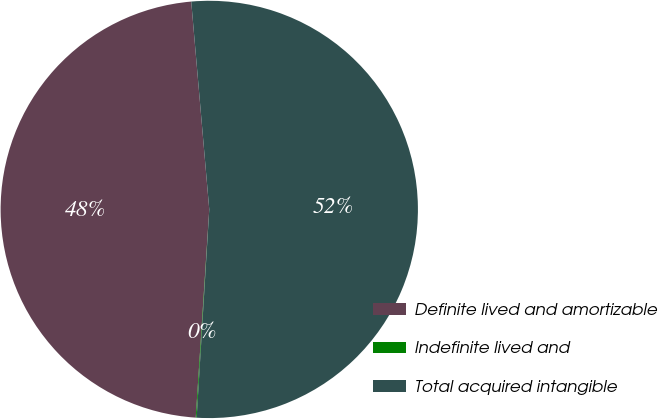<chart> <loc_0><loc_0><loc_500><loc_500><pie_chart><fcel>Definite lived and amortizable<fcel>Indefinite lived and<fcel>Total acquired intangible<nl><fcel>47.59%<fcel>0.07%<fcel>52.34%<nl></chart> 